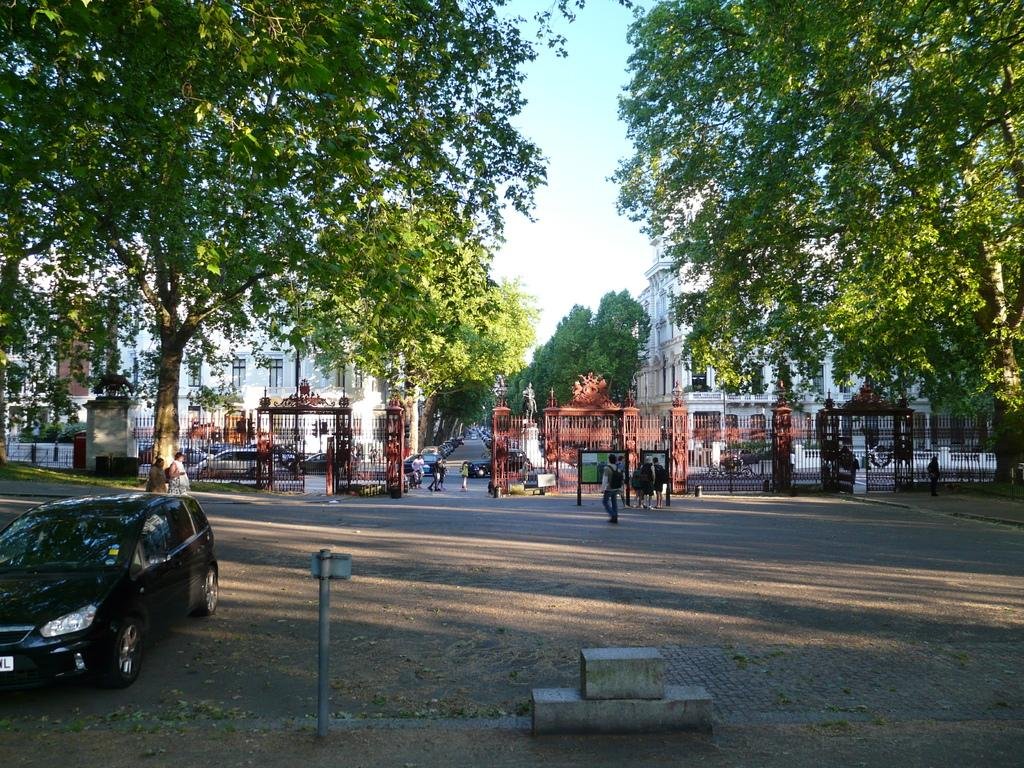Who or what is present in the image? There are people and vehicles in the image. the image. What else can be seen in the image besides people and vehicles? There are trees and buildings in the image. What is visible at the top of the image? The sky is visible at the top of the image. What type of pies are being served in the office in the image? There is no mention of pies or an office in the image; it features people, vehicles, trees, buildings, and the sky. Are the people in the image wearing stockings? There is no information about the clothing of the people in the image, so it cannot be determined if they are wearing stockings. 